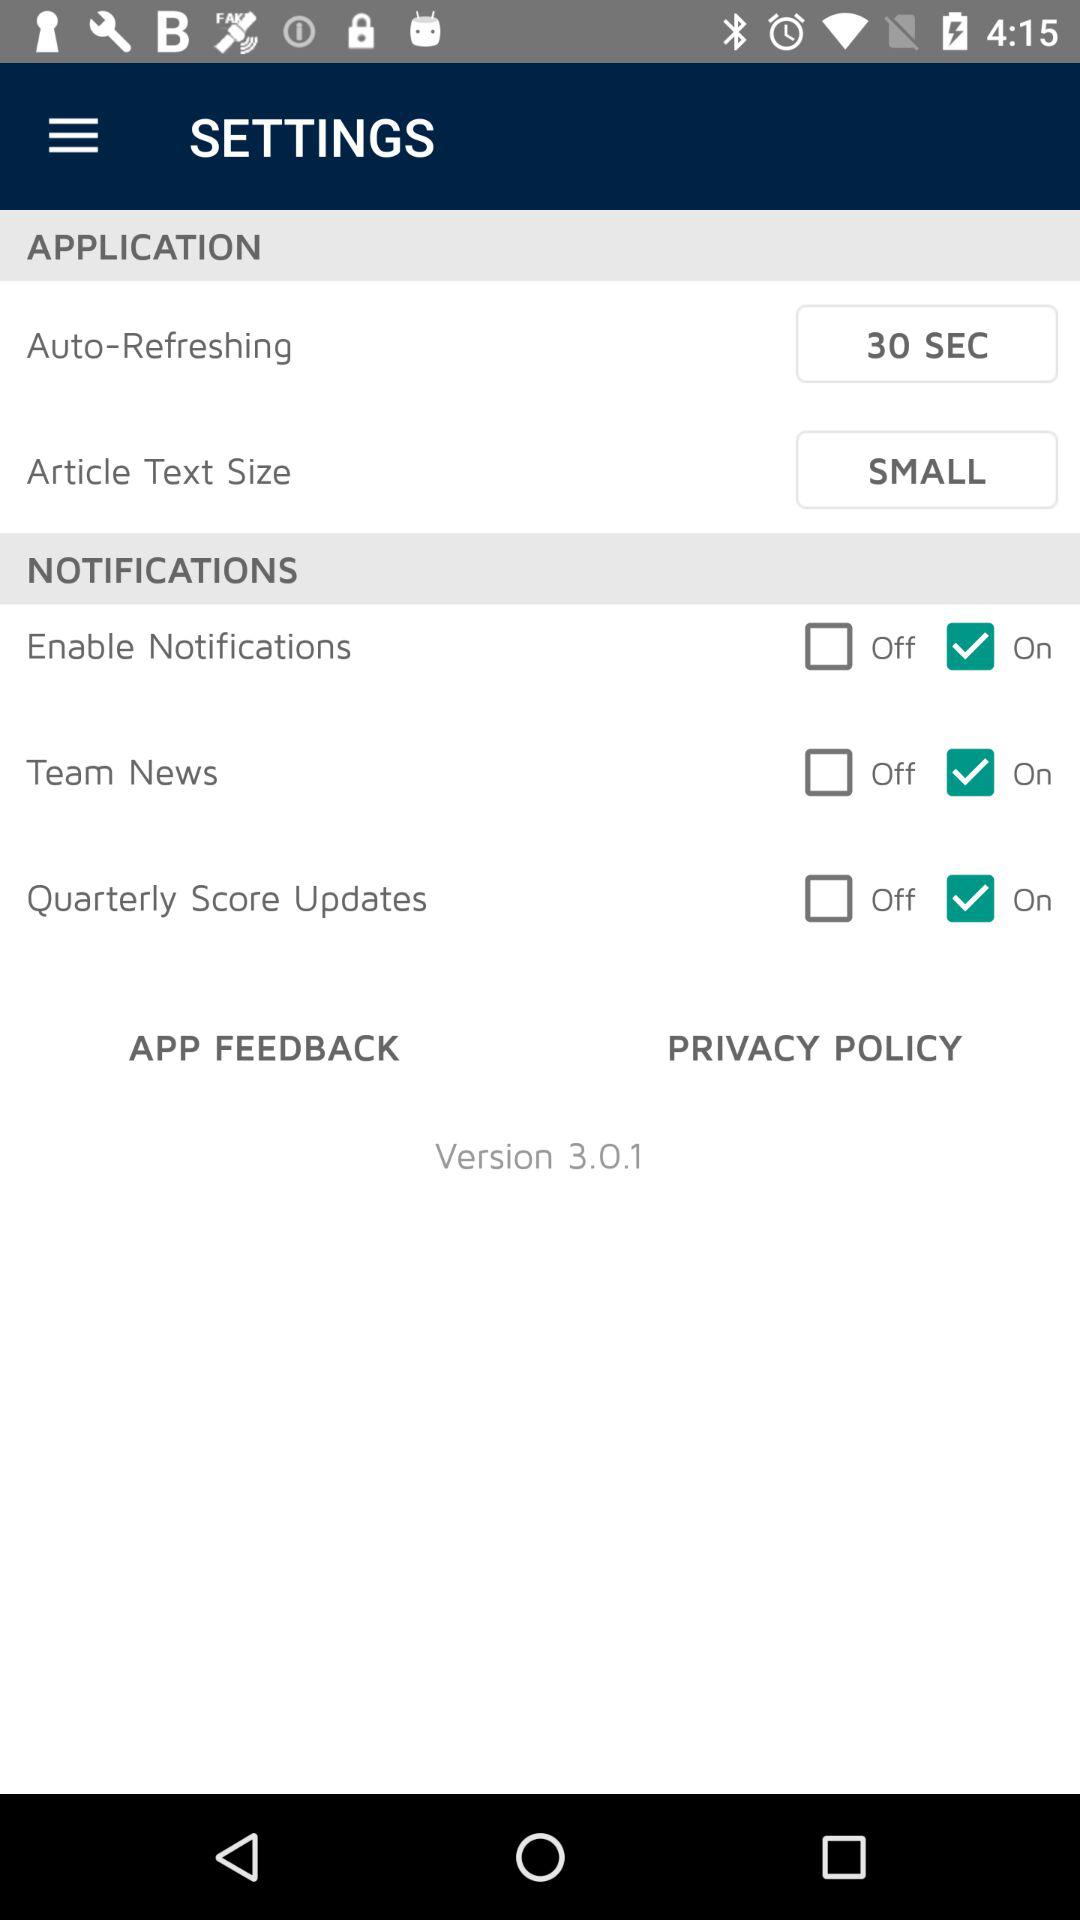What is the auto-refreshing time? The auto-refreshing time is 30 seconds. 